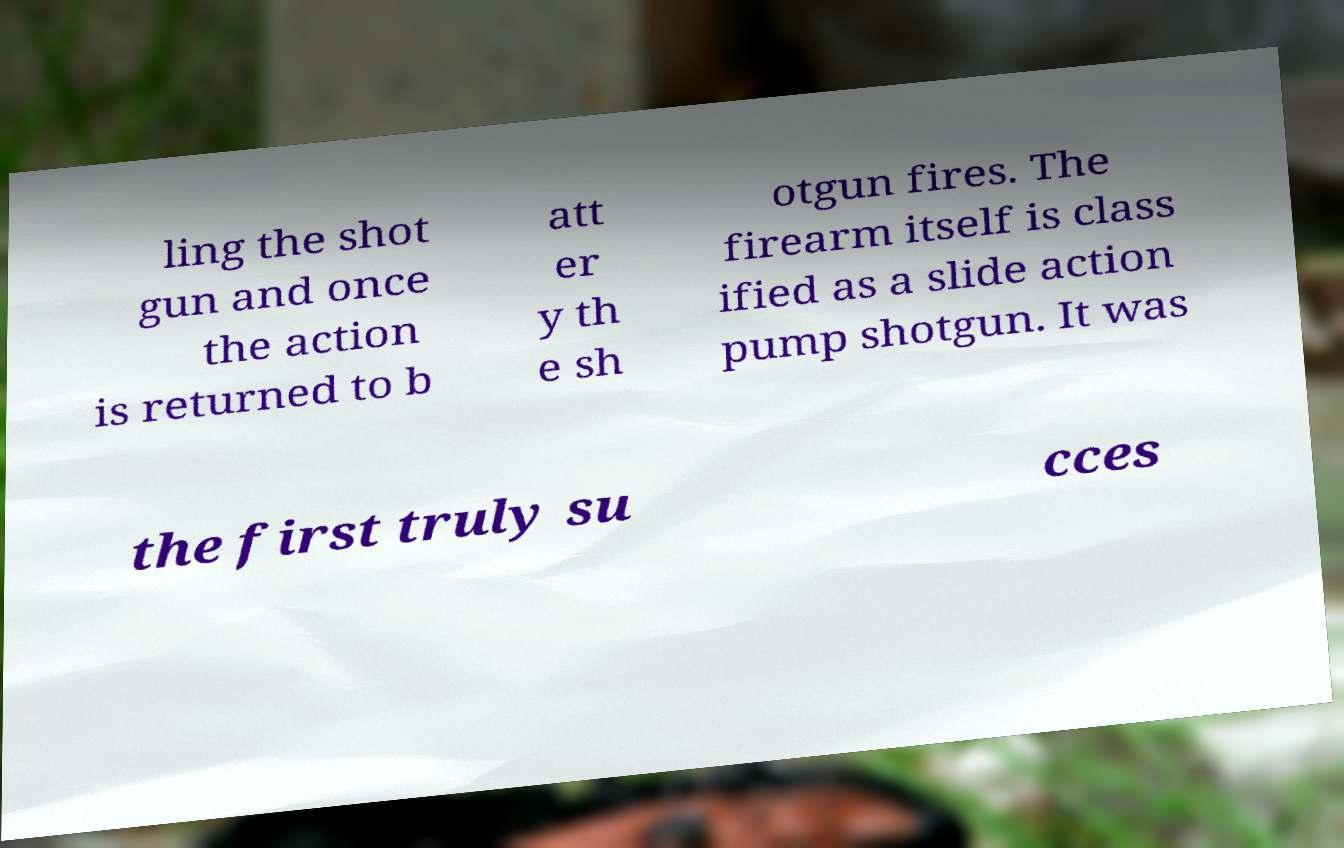Can you accurately transcribe the text from the provided image for me? ling the shot gun and once the action is returned to b att er y th e sh otgun fires. The firearm itself is class ified as a slide action pump shotgun. It was the first truly su cces 